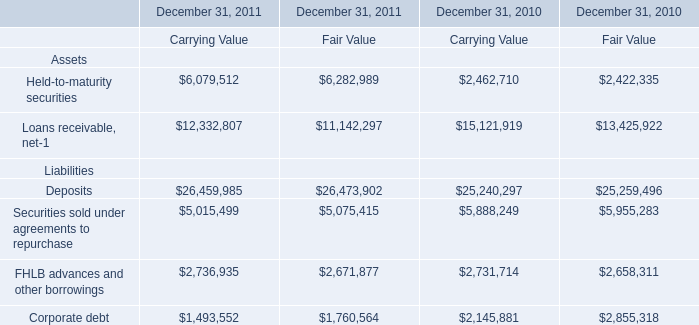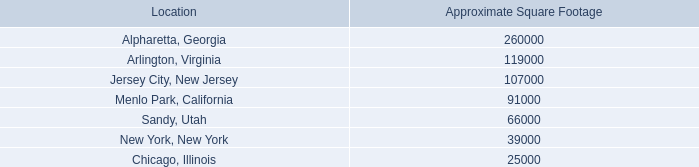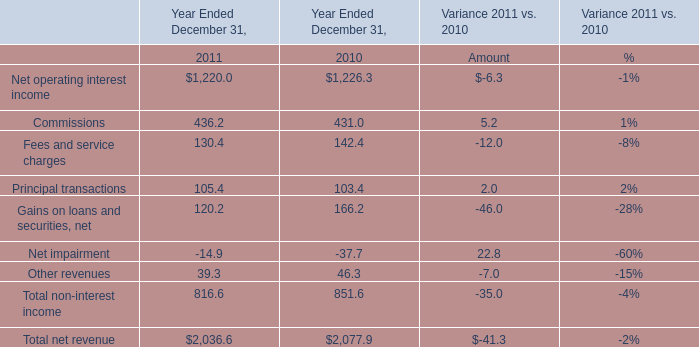What will Commissions reach in 2012 if it continues to grow at its current rate? 
Computations: ((1 + ((436.2 - 431) / 431)) * 436.2)
Answer: 441.46274. 